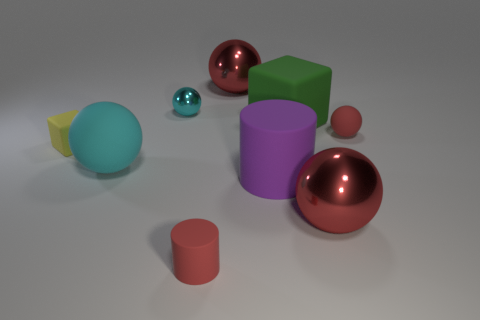Add 1 big cyan rubber spheres. How many objects exist? 10 Subtract all large cyan balls. How many balls are left? 4 Subtract all brown cubes. How many cyan balls are left? 2 Subtract all red balls. How many balls are left? 2 Subtract all blocks. How many objects are left? 7 Subtract 1 blocks. How many blocks are left? 1 Subtract all rubber blocks. Subtract all yellow cubes. How many objects are left? 6 Add 3 tiny matte spheres. How many tiny matte spheres are left? 4 Add 1 red spheres. How many red spheres exist? 4 Subtract 1 yellow cubes. How many objects are left? 8 